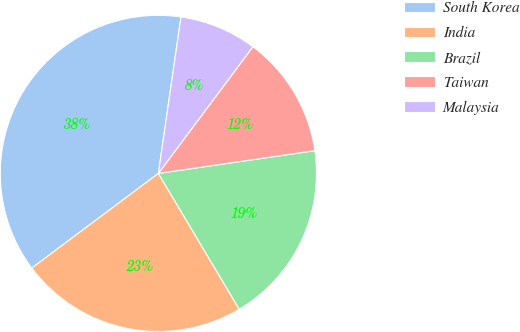<chart> <loc_0><loc_0><loc_500><loc_500><pie_chart><fcel>South Korea<fcel>India<fcel>Brazil<fcel>Taiwan<fcel>Malaysia<nl><fcel>37.5%<fcel>23.33%<fcel>18.75%<fcel>12.5%<fcel>7.92%<nl></chart> 